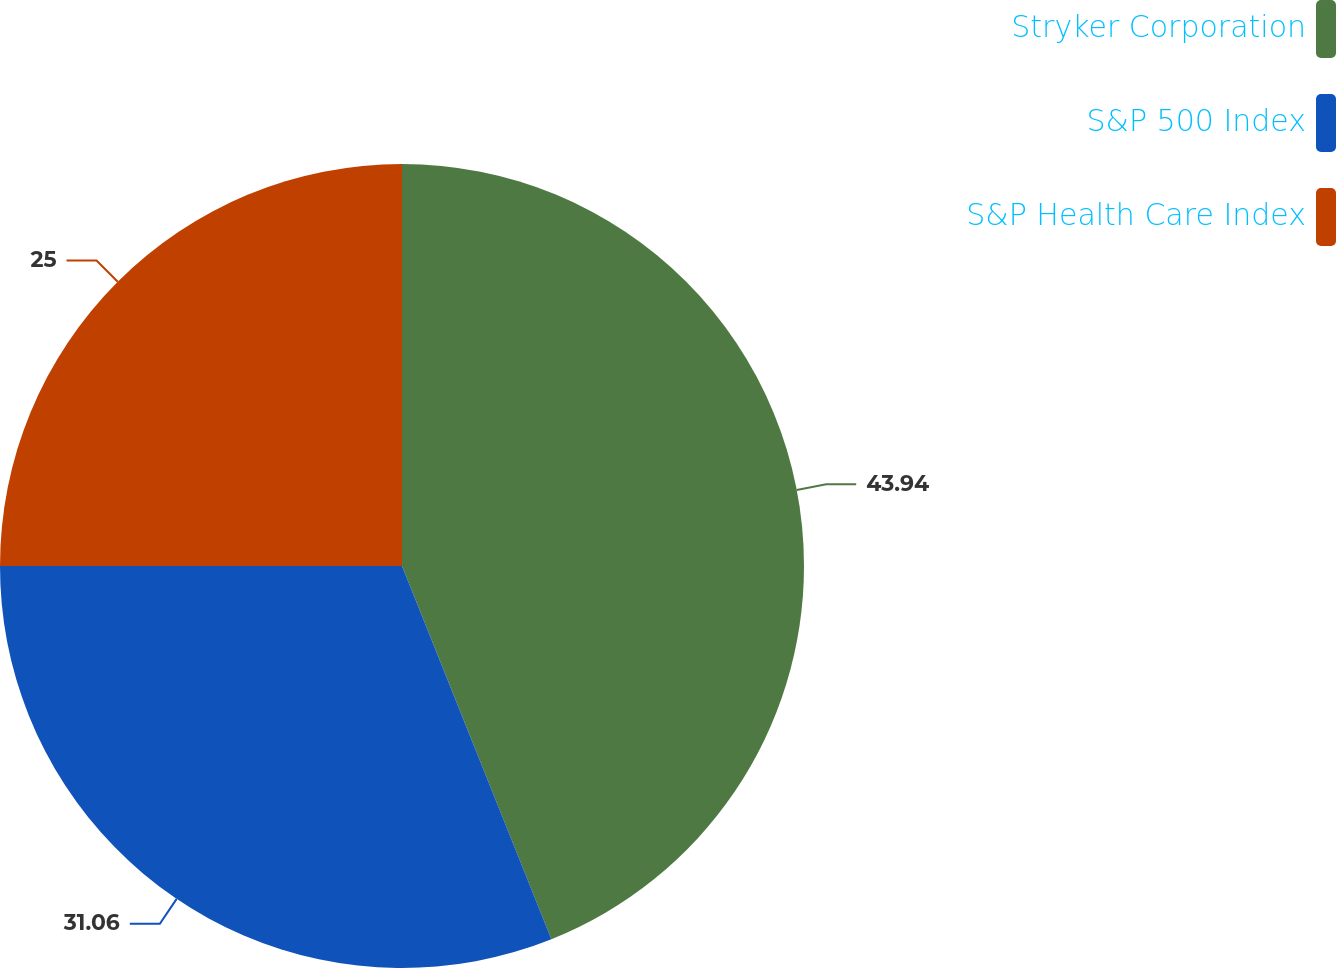Convert chart. <chart><loc_0><loc_0><loc_500><loc_500><pie_chart><fcel>Stryker Corporation<fcel>S&P 500 Index<fcel>S&P Health Care Index<nl><fcel>43.94%<fcel>31.06%<fcel>25.0%<nl></chart> 